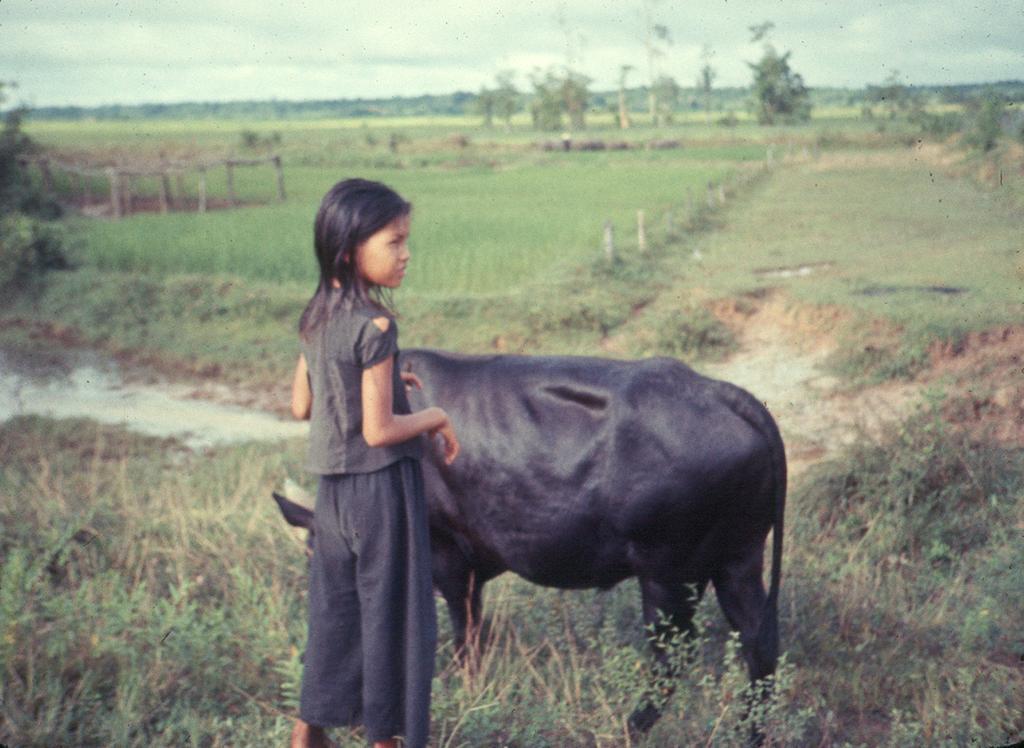Can you describe this image briefly? In this image we can see a girl standing and there is a buffalo. At the bottom there is grass. In the background there are trees and we can see a field. At the top there is sky. 